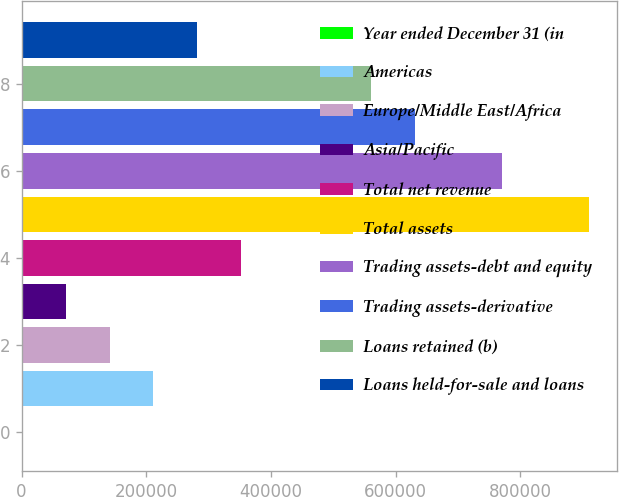<chart> <loc_0><loc_0><loc_500><loc_500><bar_chart><fcel>Year ended December 31 (in<fcel>Americas<fcel>Europe/Middle East/Africa<fcel>Asia/Pacific<fcel>Total net revenue<fcel>Total assets<fcel>Trading assets-debt and equity<fcel>Trading assets-derivative<fcel>Loans retained (b)<fcel>Loans held-for-sale and loans<nl><fcel>2007<fcel>211574<fcel>141719<fcel>71862.8<fcel>351286<fcel>910132<fcel>770421<fcel>630709<fcel>560853<fcel>281430<nl></chart> 